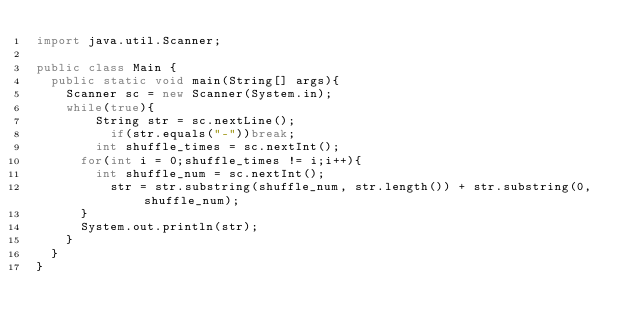Convert code to text. <code><loc_0><loc_0><loc_500><loc_500><_Java_>import java.util.Scanner;

public class Main {
	public static void main(String[] args){
		Scanner sc = new Scanner(System.in);
		while(true){	
				String str = sc.nextLine();
					if(str.equals("-"))break;
				int shuffle_times = sc.nextInt();
			for(int i = 0;shuffle_times != i;i++){
				int shuffle_num = sc.nextInt();
					str = str.substring(shuffle_num, str.length()) + str.substring(0, shuffle_num);
			}
			System.out.println(str);
		}
	}
}</code> 